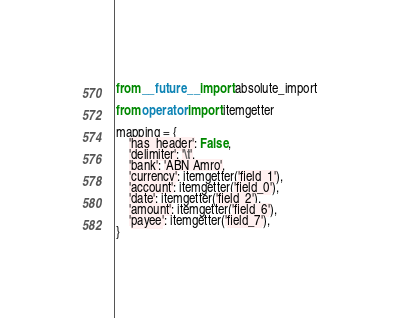Convert code to text. <code><loc_0><loc_0><loc_500><loc_500><_Python_>from __future__ import absolute_import

from operator import itemgetter

mapping = {
    'has_header': False,
    'delimiter': '\t',
    'bank': 'ABN Amro',
    'currency': itemgetter('field_1'),
    'account': itemgetter('field_0'),
    'date': itemgetter('field_2'),
    'amount': itemgetter('field_6'),
    'payee': itemgetter('field_7'),
}
</code> 